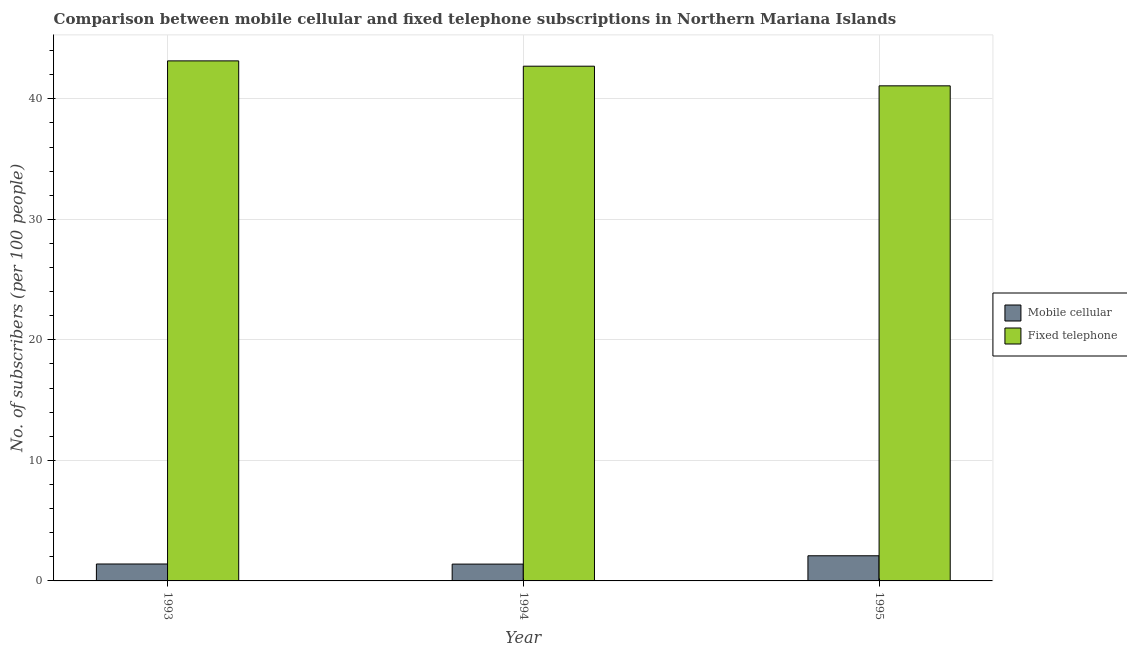How many groups of bars are there?
Provide a short and direct response. 3. Are the number of bars per tick equal to the number of legend labels?
Your answer should be very brief. Yes. How many bars are there on the 1st tick from the right?
Offer a very short reply. 2. What is the number of mobile cellular subscribers in 1995?
Your answer should be compact. 2.09. Across all years, what is the maximum number of fixed telephone subscribers?
Give a very brief answer. 43.15. Across all years, what is the minimum number of fixed telephone subscribers?
Give a very brief answer. 41.08. In which year was the number of fixed telephone subscribers maximum?
Provide a short and direct response. 1993. In which year was the number of mobile cellular subscribers minimum?
Provide a succinct answer. 1994. What is the total number of fixed telephone subscribers in the graph?
Your answer should be very brief. 126.93. What is the difference between the number of fixed telephone subscribers in 1993 and that in 1994?
Offer a terse response. 0.44. What is the difference between the number of fixed telephone subscribers in 1994 and the number of mobile cellular subscribers in 1993?
Provide a succinct answer. -0.44. What is the average number of mobile cellular subscribers per year?
Provide a succinct answer. 1.63. What is the ratio of the number of mobile cellular subscribers in 1994 to that in 1995?
Ensure brevity in your answer.  0.67. What is the difference between the highest and the second highest number of fixed telephone subscribers?
Your answer should be very brief. 0.44. What is the difference between the highest and the lowest number of mobile cellular subscribers?
Offer a terse response. 0.69. What does the 2nd bar from the left in 1994 represents?
Offer a very short reply. Fixed telephone. What does the 1st bar from the right in 1994 represents?
Your response must be concise. Fixed telephone. How many bars are there?
Ensure brevity in your answer.  6. Are all the bars in the graph horizontal?
Ensure brevity in your answer.  No. How many years are there in the graph?
Your response must be concise. 3. What is the difference between two consecutive major ticks on the Y-axis?
Your answer should be compact. 10. Are the values on the major ticks of Y-axis written in scientific E-notation?
Your answer should be compact. No. Does the graph contain grids?
Make the answer very short. Yes. Where does the legend appear in the graph?
Provide a succinct answer. Center right. How are the legend labels stacked?
Make the answer very short. Vertical. What is the title of the graph?
Make the answer very short. Comparison between mobile cellular and fixed telephone subscriptions in Northern Mariana Islands. Does "Under-five" appear as one of the legend labels in the graph?
Provide a succinct answer. No. What is the label or title of the Y-axis?
Give a very brief answer. No. of subscribers (per 100 people). What is the No. of subscribers (per 100 people) in Mobile cellular in 1993?
Keep it short and to the point. 1.4. What is the No. of subscribers (per 100 people) of Fixed telephone in 1993?
Your response must be concise. 43.15. What is the No. of subscribers (per 100 people) in Mobile cellular in 1994?
Provide a succinct answer. 1.4. What is the No. of subscribers (per 100 people) in Fixed telephone in 1994?
Ensure brevity in your answer.  42.71. What is the No. of subscribers (per 100 people) of Mobile cellular in 1995?
Make the answer very short. 2.09. What is the No. of subscribers (per 100 people) in Fixed telephone in 1995?
Your answer should be very brief. 41.08. Across all years, what is the maximum No. of subscribers (per 100 people) of Mobile cellular?
Provide a succinct answer. 2.09. Across all years, what is the maximum No. of subscribers (per 100 people) of Fixed telephone?
Provide a succinct answer. 43.15. Across all years, what is the minimum No. of subscribers (per 100 people) of Mobile cellular?
Provide a succinct answer. 1.4. Across all years, what is the minimum No. of subscribers (per 100 people) of Fixed telephone?
Make the answer very short. 41.08. What is the total No. of subscribers (per 100 people) in Mobile cellular in the graph?
Give a very brief answer. 4.89. What is the total No. of subscribers (per 100 people) of Fixed telephone in the graph?
Keep it short and to the point. 126.93. What is the difference between the No. of subscribers (per 100 people) in Mobile cellular in 1993 and that in 1994?
Your answer should be very brief. 0.01. What is the difference between the No. of subscribers (per 100 people) in Fixed telephone in 1993 and that in 1994?
Offer a terse response. 0.44. What is the difference between the No. of subscribers (per 100 people) in Mobile cellular in 1993 and that in 1995?
Give a very brief answer. -0.68. What is the difference between the No. of subscribers (per 100 people) in Fixed telephone in 1993 and that in 1995?
Make the answer very short. 2.07. What is the difference between the No. of subscribers (per 100 people) of Mobile cellular in 1994 and that in 1995?
Your answer should be compact. -0.69. What is the difference between the No. of subscribers (per 100 people) in Fixed telephone in 1994 and that in 1995?
Your answer should be compact. 1.63. What is the difference between the No. of subscribers (per 100 people) of Mobile cellular in 1993 and the No. of subscribers (per 100 people) of Fixed telephone in 1994?
Offer a very short reply. -41.3. What is the difference between the No. of subscribers (per 100 people) in Mobile cellular in 1993 and the No. of subscribers (per 100 people) in Fixed telephone in 1995?
Give a very brief answer. -39.67. What is the difference between the No. of subscribers (per 100 people) of Mobile cellular in 1994 and the No. of subscribers (per 100 people) of Fixed telephone in 1995?
Offer a very short reply. -39.68. What is the average No. of subscribers (per 100 people) in Mobile cellular per year?
Your response must be concise. 1.63. What is the average No. of subscribers (per 100 people) of Fixed telephone per year?
Your answer should be compact. 42.31. In the year 1993, what is the difference between the No. of subscribers (per 100 people) in Mobile cellular and No. of subscribers (per 100 people) in Fixed telephone?
Make the answer very short. -41.74. In the year 1994, what is the difference between the No. of subscribers (per 100 people) in Mobile cellular and No. of subscribers (per 100 people) in Fixed telephone?
Provide a succinct answer. -41.31. In the year 1995, what is the difference between the No. of subscribers (per 100 people) in Mobile cellular and No. of subscribers (per 100 people) in Fixed telephone?
Your response must be concise. -38.99. What is the ratio of the No. of subscribers (per 100 people) of Mobile cellular in 1993 to that in 1994?
Keep it short and to the point. 1.01. What is the ratio of the No. of subscribers (per 100 people) of Fixed telephone in 1993 to that in 1994?
Ensure brevity in your answer.  1.01. What is the ratio of the No. of subscribers (per 100 people) of Mobile cellular in 1993 to that in 1995?
Make the answer very short. 0.67. What is the ratio of the No. of subscribers (per 100 people) in Fixed telephone in 1993 to that in 1995?
Your answer should be very brief. 1.05. What is the ratio of the No. of subscribers (per 100 people) in Mobile cellular in 1994 to that in 1995?
Offer a very short reply. 0.67. What is the ratio of the No. of subscribers (per 100 people) of Fixed telephone in 1994 to that in 1995?
Keep it short and to the point. 1.04. What is the difference between the highest and the second highest No. of subscribers (per 100 people) in Mobile cellular?
Your answer should be very brief. 0.68. What is the difference between the highest and the second highest No. of subscribers (per 100 people) in Fixed telephone?
Offer a very short reply. 0.44. What is the difference between the highest and the lowest No. of subscribers (per 100 people) in Mobile cellular?
Provide a short and direct response. 0.69. What is the difference between the highest and the lowest No. of subscribers (per 100 people) in Fixed telephone?
Your answer should be compact. 2.07. 